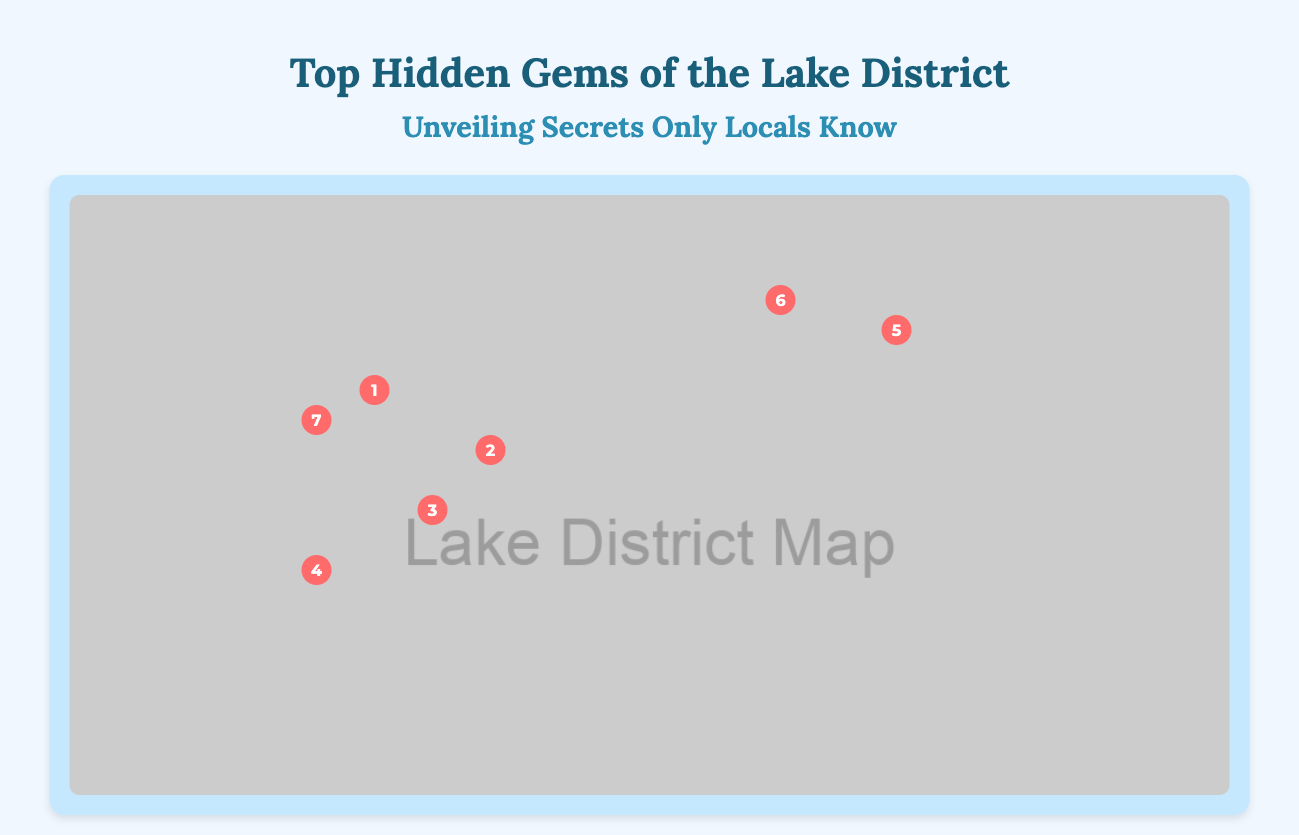What is the title of the infographic? The title of the infographic is provided at the top of the document.
Answer: Top Hidden Gems of the Lake District How many hidden gems are highlighted in the infographic? The number of hidden gems can be counted from the locations indicated on the map.
Answer: Seven What does the icon next to Claife indicate? The icon next to Claife shows a viewing tower, which represents the location associated with this gem.
Answer: Viewing Tower What is the location of Rydal Cave? The position of Rydal Cave is indicated on the map using its coordinates, which can be visually located.
Answer: 40% down, 35% across What type of location is Tarn Hows? The description of Tarn Hows indicates what kind of place it is and its primary features.
Answer: Picturesque tarn What historical significance does Hardknott have? The information about Hardknott mentions its connection to Roman history, indicating its importance.
Answer: Ancient Roman fort Which location is associated with literary connections? The infographic provides a brief description of a specific location related to literature.
Answer: Mirehouse and Gardens What is unique about Whinlatter Forest Park? Whinlatter is identified in the document as England's only true mountain forest, which highlights its distinct characteristic.
Answer: True mountain forest 